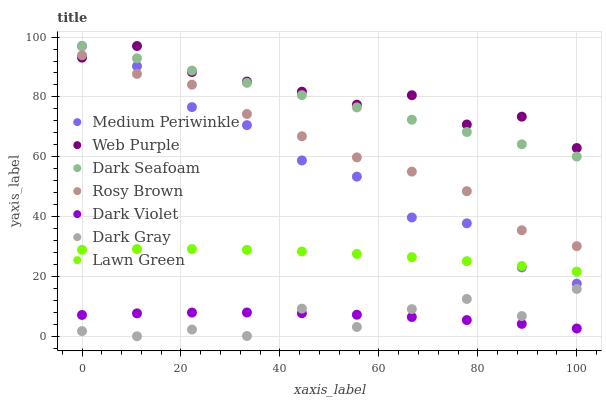Does Dark Gray have the minimum area under the curve?
Answer yes or no. Yes. Does Web Purple have the maximum area under the curve?
Answer yes or no. Yes. Does Rosy Brown have the minimum area under the curve?
Answer yes or no. No. Does Rosy Brown have the maximum area under the curve?
Answer yes or no. No. Is Dark Seafoam the smoothest?
Answer yes or no. Yes. Is Dark Gray the roughest?
Answer yes or no. Yes. Is Rosy Brown the smoothest?
Answer yes or no. No. Is Rosy Brown the roughest?
Answer yes or no. No. Does Dark Gray have the lowest value?
Answer yes or no. Yes. Does Rosy Brown have the lowest value?
Answer yes or no. No. Does Web Purple have the highest value?
Answer yes or no. Yes. Does Rosy Brown have the highest value?
Answer yes or no. No. Is Dark Gray less than Medium Periwinkle?
Answer yes or no. Yes. Is Rosy Brown greater than Lawn Green?
Answer yes or no. Yes. Does Dark Violet intersect Dark Gray?
Answer yes or no. Yes. Is Dark Violet less than Dark Gray?
Answer yes or no. No. Is Dark Violet greater than Dark Gray?
Answer yes or no. No. Does Dark Gray intersect Medium Periwinkle?
Answer yes or no. No. 